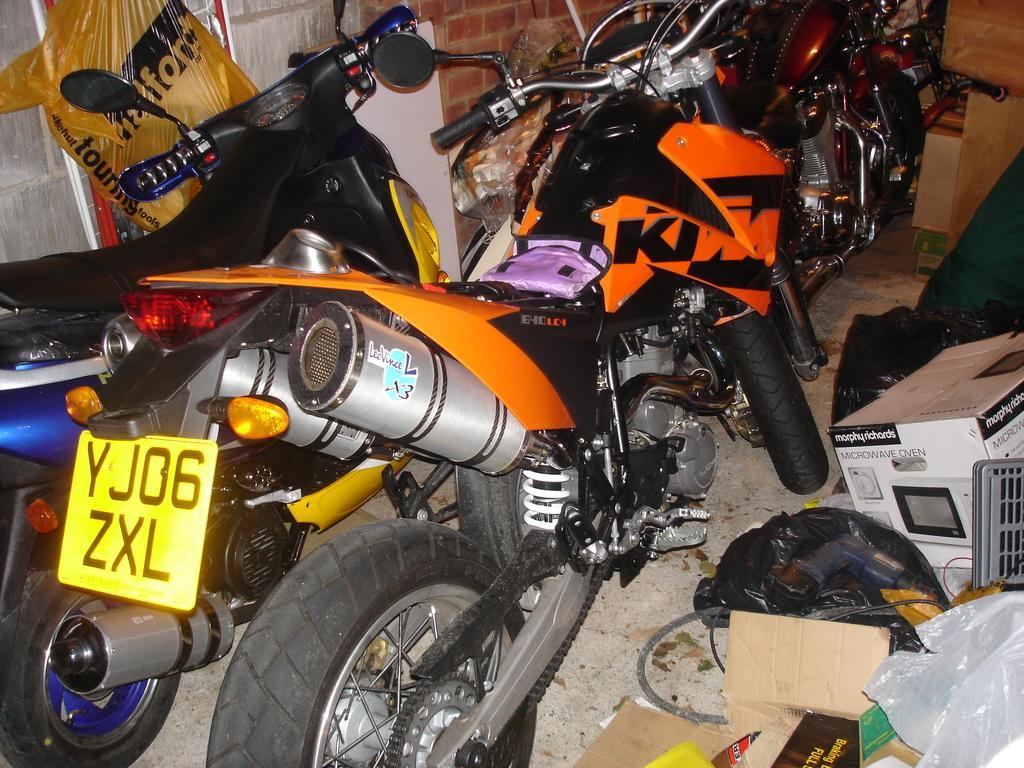How would you summarize this image in a sentence or two? In the image there are motorbikes and beside the bikes there are some boxes, in the background there is a brick wall. 